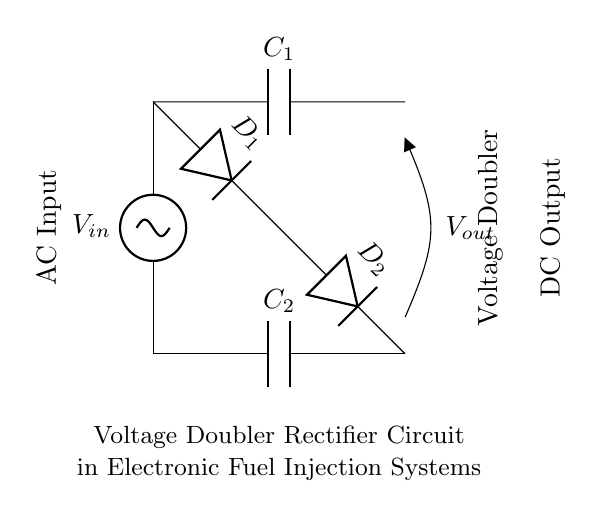What is the purpose of the capacitors in this circuit? The capacitors, C1 and C2, are used to store electrical energy and filter the output voltage. They smooth out the pulsating DC voltage produced by the diodes.
Answer: Store energy What component is used for rectification in this circuit? The diodes D1 and D2 are used for rectification, allowing current to flow in one direction and converting AC voltage to DC voltage.
Answer: Diodes What is the relationship between VIN and VOUT in this voltage doubler? In a voltage doubler circuit, VOUT is ideally double VIN due to the configuration of the capacitors and diodes.
Answer: VOUT = 2 VIN How many diodes are present in this circuit? There are two diodes, D1 and D2, which work together to convert the AC input into a doubled DC output.
Answer: Two What is the main function of this voltage doubler rectifier in electronic fuel injection systems? This circuit increases the voltage available for the fuel injection system by converting AC input from sensors or ignition sources into a higher DC voltage needed for operation.
Answer: Increase voltage In what configuration are the diodes arranged in this circuit? The diodes are arranged in a series-parallel configuration, enabling the circuit to maintain voltage polarity and achieve voltage doubling during the AC cycle.
Answer: Series-parallel 